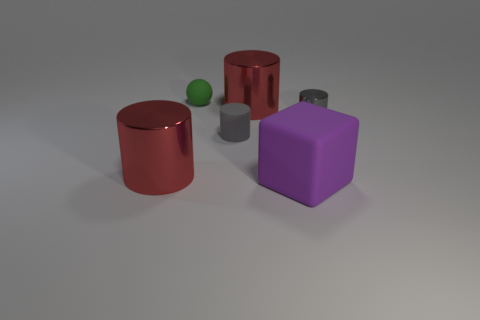Subtract all red cylinders. How many were subtracted if there are1red cylinders left? 1 Add 3 cylinders. How many objects exist? 9 Subtract all balls. How many objects are left? 5 Subtract 0 gray blocks. How many objects are left? 6 Subtract all yellow rubber cylinders. Subtract all big blocks. How many objects are left? 5 Add 2 big rubber cubes. How many big rubber cubes are left? 3 Add 4 large green balls. How many large green balls exist? 4 